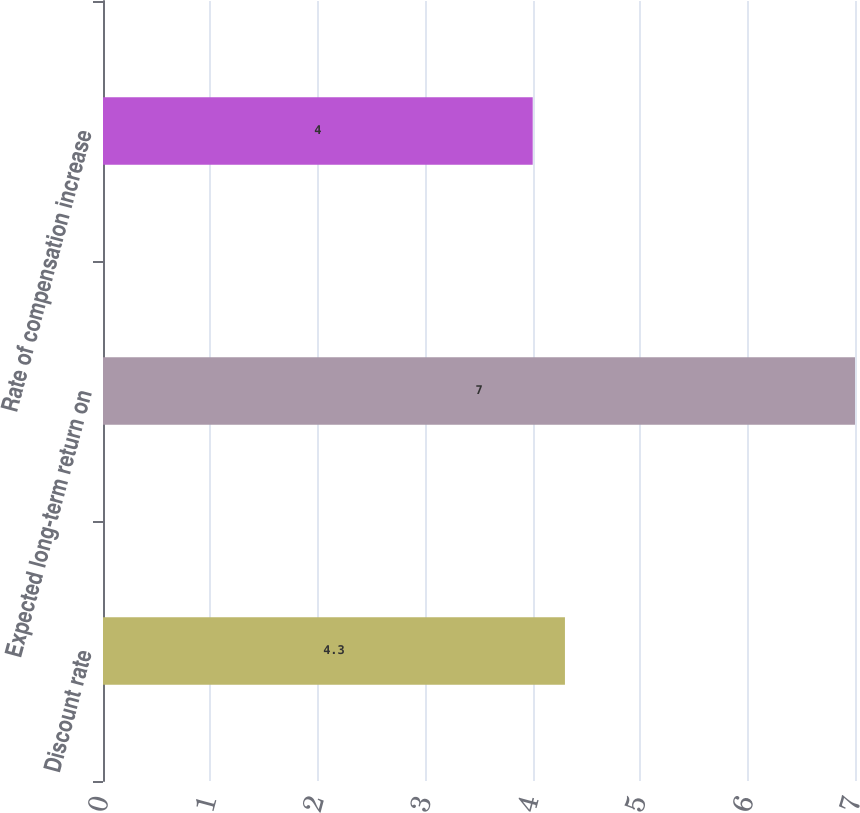Convert chart. <chart><loc_0><loc_0><loc_500><loc_500><bar_chart><fcel>Discount rate<fcel>Expected long-term return on<fcel>Rate of compensation increase<nl><fcel>4.3<fcel>7<fcel>4<nl></chart> 